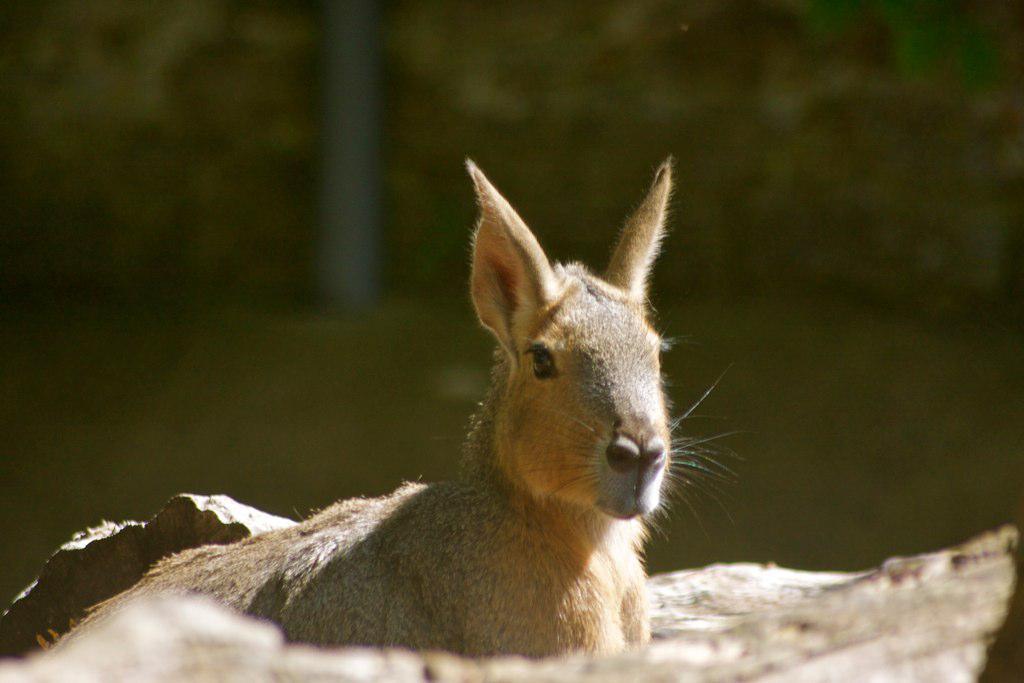In one or two sentences, can you explain what this image depicts? In this image there is an animal towards the bottom of the image, there is an object towards the bottom of the image, the background of the image is blurred. 